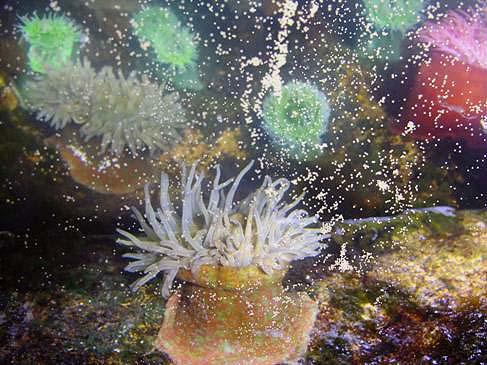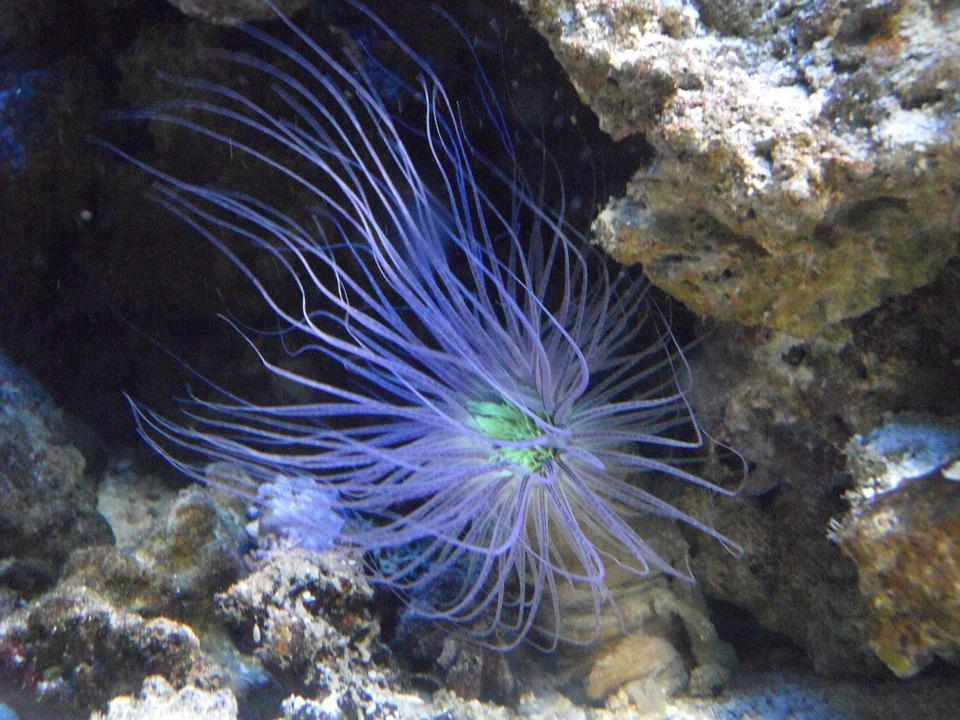The first image is the image on the left, the second image is the image on the right. Examine the images to the left and right. Is the description "There are at least two clown fish." accurate? Answer yes or no. No. 